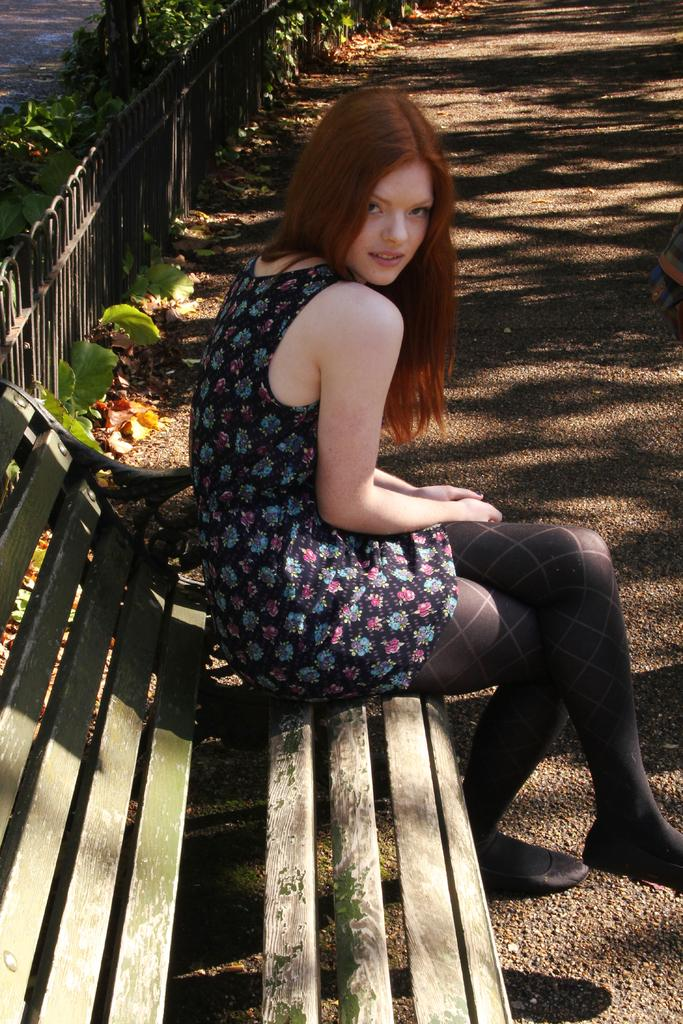Who is the main subject in the image? There is a girl in the image. What is the girl doing in the image? The girl is sitting on a wooden bench and giving a pose to the camera. What is the girl's facial expression in the image? The girl is smiling in the image. What can be seen in the background of the image? There is a black fencing railing and green plants in the background. What type of tomatoes can be seen growing on the girl's head in the image? There are no tomatoes present in the image, nor are they growing on the girl's head. 